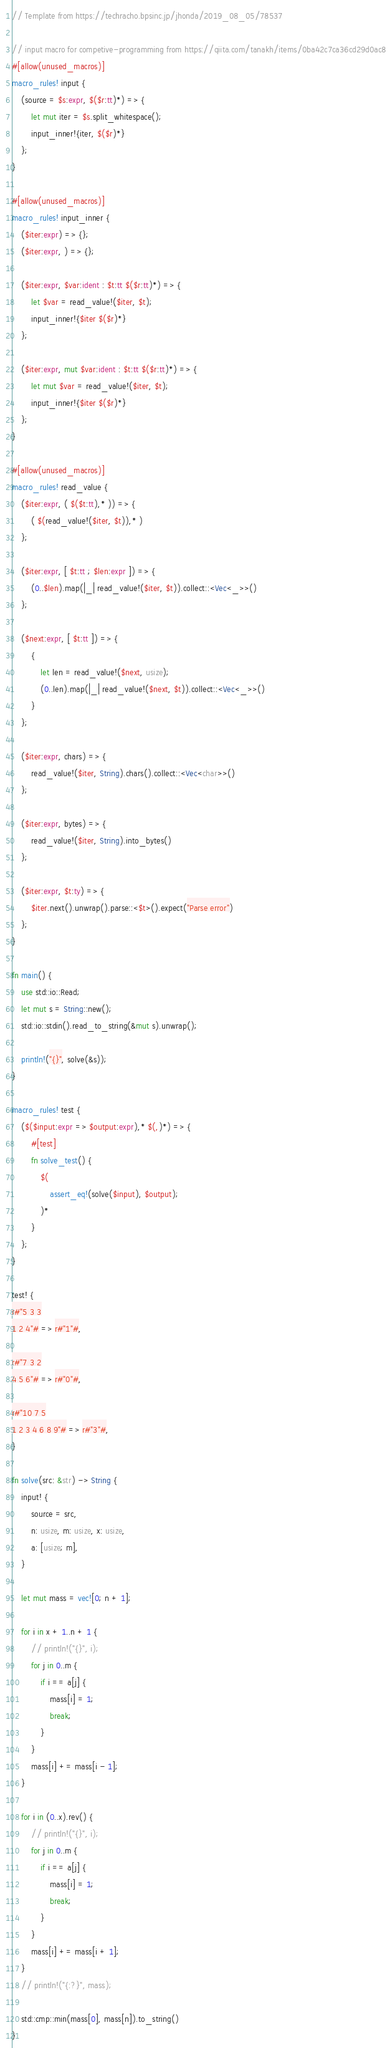Convert code to text. <code><loc_0><loc_0><loc_500><loc_500><_Rust_>// Template from https://techracho.bpsinc.jp/jhonda/2019_08_05/78537

// input macro for competive-programming from https://qiita.com/tanakh/items/0ba42c7ca36cd29d0ac8
#[allow(unused_macros)]
macro_rules! input {
    (source = $s:expr, $($r:tt)*) => {
        let mut iter = $s.split_whitespace();
        input_inner!{iter, $($r)*}
    };
}

#[allow(unused_macros)]
macro_rules! input_inner {
    ($iter:expr) => {};
    ($iter:expr, ) => {};

    ($iter:expr, $var:ident : $t:tt $($r:tt)*) => {
        let $var = read_value!($iter, $t);
        input_inner!{$iter $($r)*}
    };

    ($iter:expr, mut $var:ident : $t:tt $($r:tt)*) => {
        let mut $var = read_value!($iter, $t);
        input_inner!{$iter $($r)*}
    };
}

#[allow(unused_macros)]
macro_rules! read_value {
    ($iter:expr, ( $($t:tt),* )) => {
        ( $(read_value!($iter, $t)),* )
    };

    ($iter:expr, [ $t:tt ; $len:expr ]) => {
        (0..$len).map(|_| read_value!($iter, $t)).collect::<Vec<_>>()
    };

    ($next:expr, [ $t:tt ]) => {
        {
            let len = read_value!($next, usize);
            (0..len).map(|_| read_value!($next, $t)).collect::<Vec<_>>()
        }
    };

    ($iter:expr, chars) => {
        read_value!($iter, String).chars().collect::<Vec<char>>()
    };

    ($iter:expr, bytes) => {
        read_value!($iter, String).into_bytes()
    };

    ($iter:expr, $t:ty) => {
        $iter.next().unwrap().parse::<$t>().expect("Parse error")
    };
}

fn main() {
    use std::io::Read;
    let mut s = String::new();
    std::io::stdin().read_to_string(&mut s).unwrap();

    println!("{}", solve(&s));
}

macro_rules! test {
    ($($input:expr => $output:expr),* $(,)*) => {
        #[test]
        fn solve_test() {
            $(
                assert_eq!(solve($input), $output);
            )*
        }
    };
}

test! {
r#"5 3 3
1 2 4"# => r#"1"#,

r#"7 3 2
4 5 6"# => r#"0"#,

r#"10 7 5
1 2 3 4 6 8 9"# => r#"3"#,
}

fn solve(src: &str) -> String {
    input! {
        source = src,
        n: usize, m: usize, x: usize,
        a: [usize; m],
    }

    let mut mass = vec![0; n + 1];

    for i in x + 1..n + 1 {
        // println!("{}", i);
        for j in 0..m {
            if i == a[j] {
                mass[i] = 1;
                break;
            }
        }
        mass[i] += mass[i - 1];
    }

    for i in (0..x).rev() {
        // println!("{}", i);
        for j in 0..m {
            if i == a[j] {
                mass[i] = 1;
                break;
            }
        }
        mass[i] += mass[i + 1];
    }
    // println!("{:?}", mass);

    std::cmp::min(mass[0], mass[n]).to_string()
}</code> 